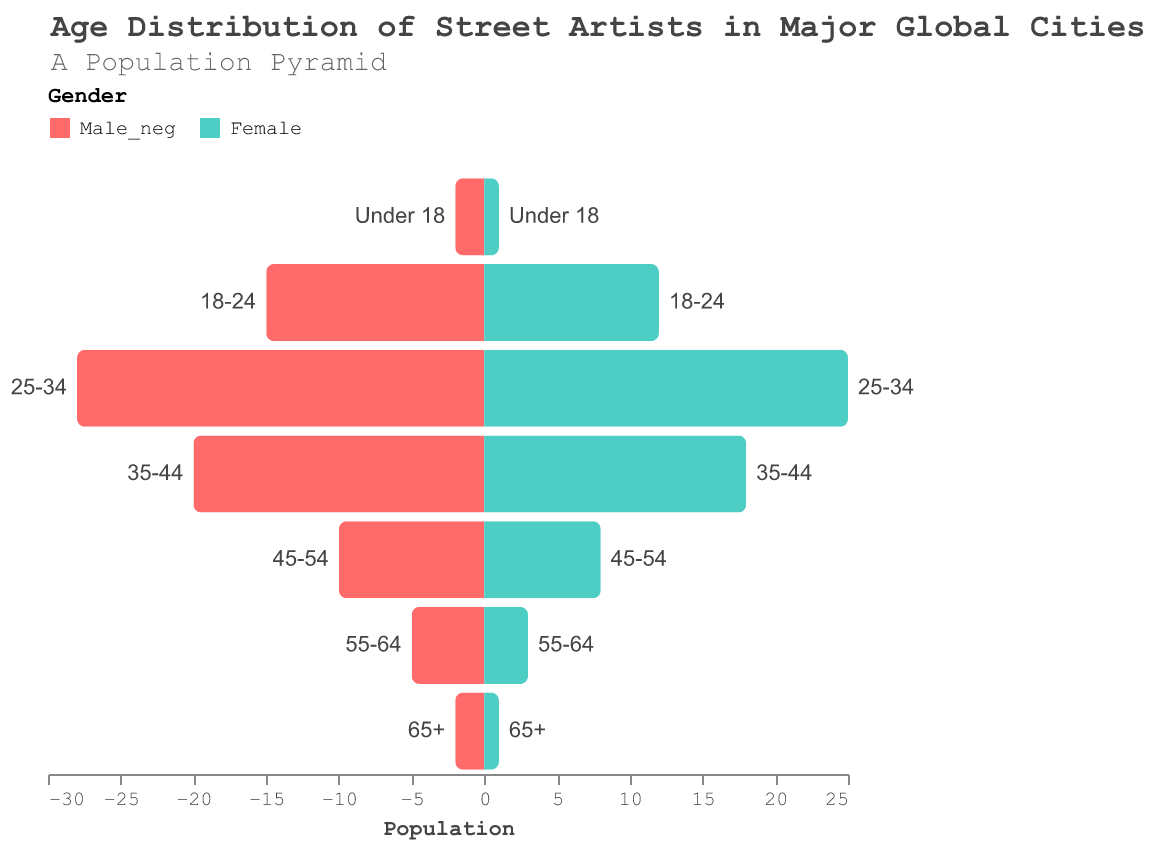What's the title of the figure? The title is prominent at the top of the figure and contains textual information about the content depicted.
Answer: Age Distribution of Street Artists in Major Global Cities Which age group has the highest number of female street artists? By looking at the bars representing female populations, the age group with the longest bar indicates the highest number.
Answer: 25-34 Which gender has more under-18 street artists? Compare the length of the bars for males and females in the "Under 18" category.
Answer: Male What's the total number of street artists aged 55-64? Sum the populations of both males and females in the 55-64 age group.
Answer: 8 How many more male street artists are there than female in the 45-54 age group? Subtract the number of female artists from the number of male artists in the 45-54 age group.
Answer: 2 Which age group shows the greatest disparity between male and female street artists? Calculate the difference between male and female artists for each age group and find the maximum difference.
Answer: 18-24 What's the proportion of male to female artists in the 25-34 age group? Divide the number of males by the number of females in the 25-34 age group.
Answer: 28:25 Do any age groups have an equal number of male and female street artists? Check all age groups to see if the male and female counts are equal.
Answer: No Which gender has more street artists aged 65+? Compare the bar lengths of males and females in the 65+ age group.
Answer: Male Comparing both genders, in which age group do street artists show the least government advocacy or involvement? Identify the age group with the smallest total population (sum of males and females).
Answer: 65+ 